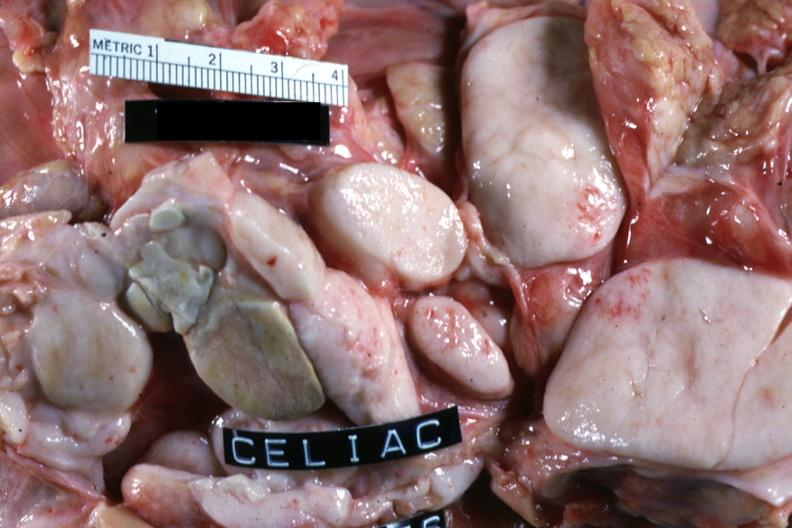what is present?
Answer the question using a single word or phrase. Lymph node 